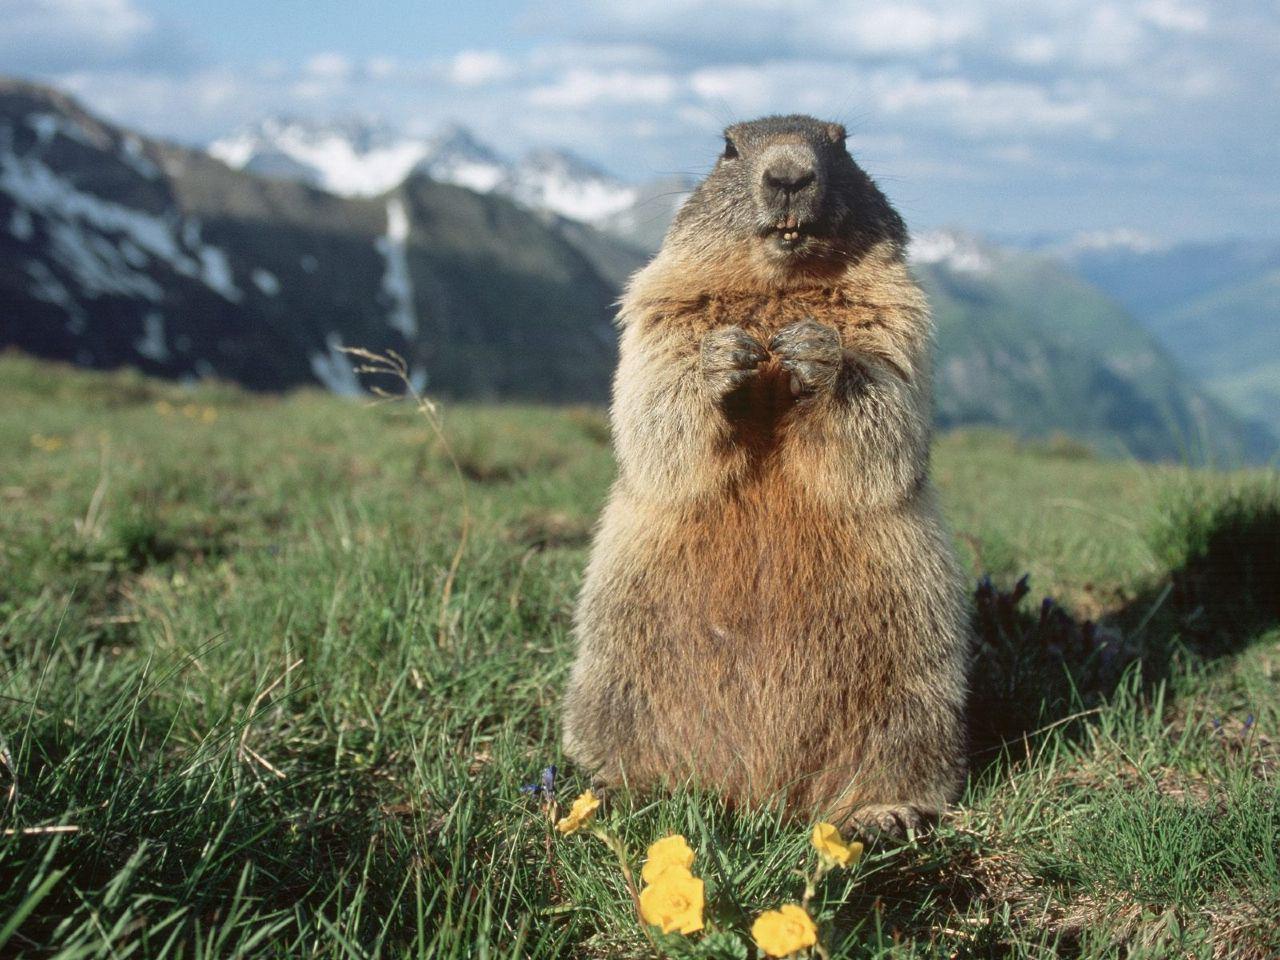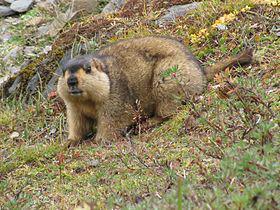The first image is the image on the left, the second image is the image on the right. Assess this claim about the two images: "Two animals are on a rocky ledge.". Correct or not? Answer yes or no. No. The first image is the image on the left, the second image is the image on the right. For the images displayed, is the sentence "One imag shows a single marmot with hands together lifted in front of its body." factually correct? Answer yes or no. Yes. 